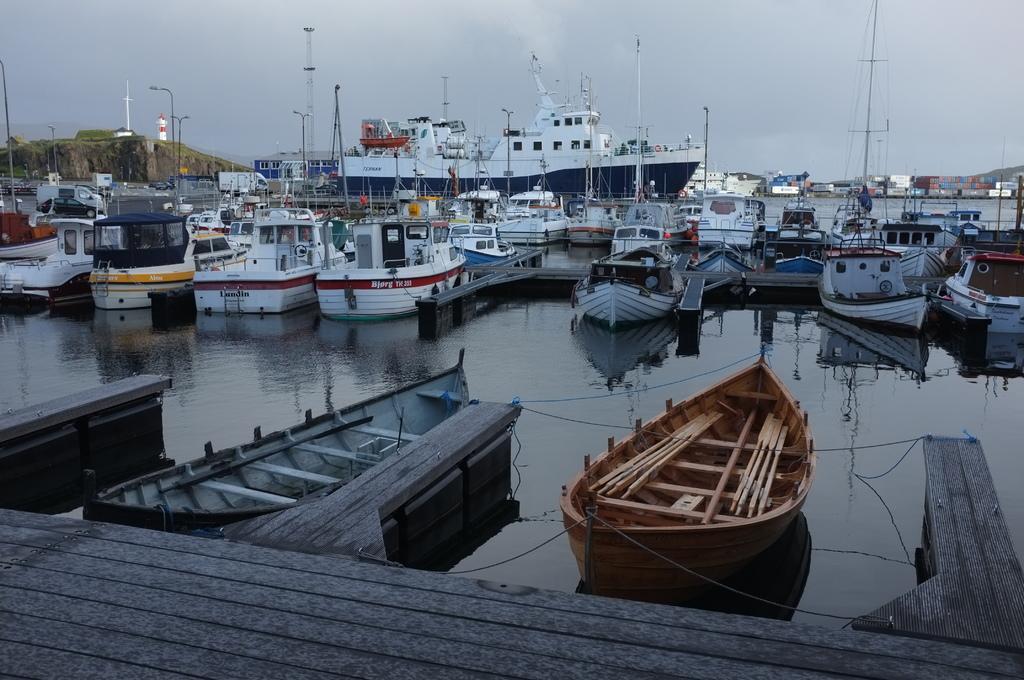Could you give a brief overview of what you see in this image? In this image we can see ships and boats are on the surface of water. The sky is covered with clouds. Bottom of the image wooden surface is present. 